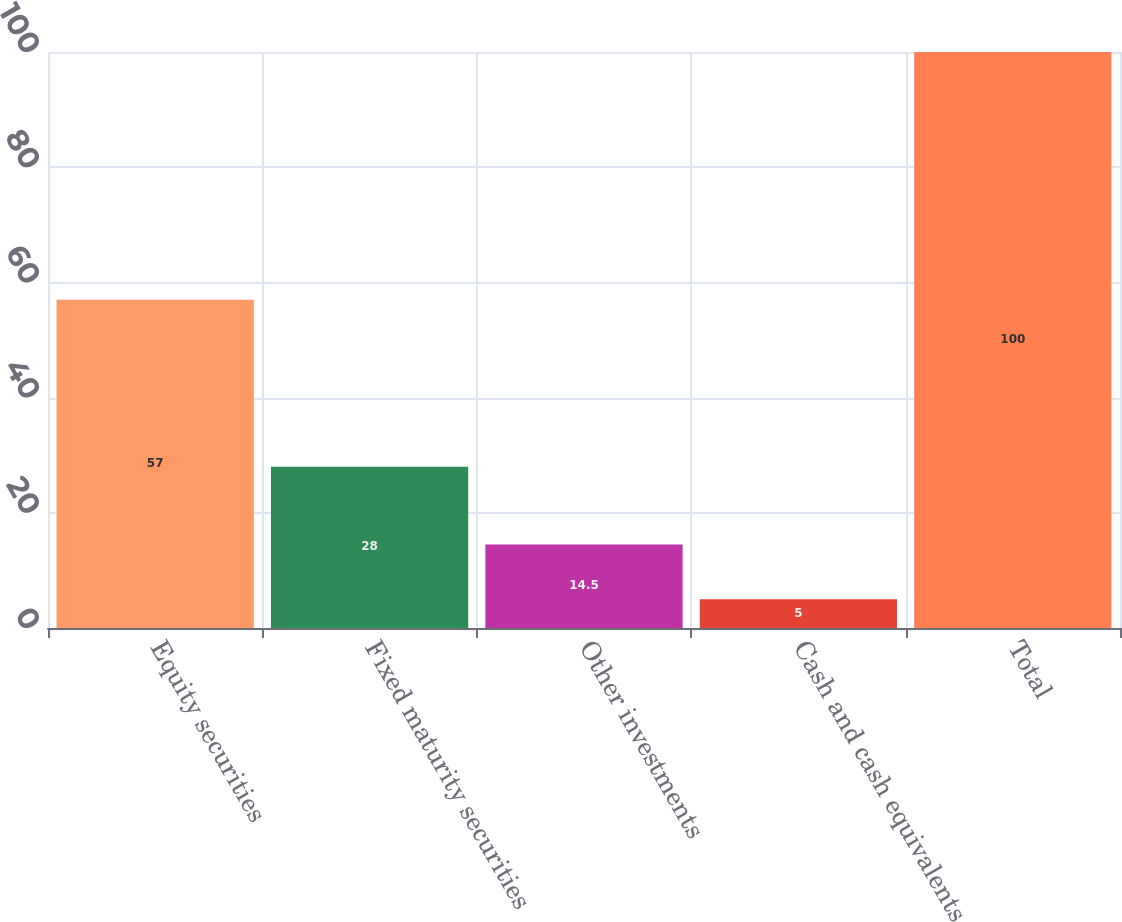Convert chart. <chart><loc_0><loc_0><loc_500><loc_500><bar_chart><fcel>Equity securities<fcel>Fixed maturity securities<fcel>Other investments<fcel>Cash and cash equivalents<fcel>Total<nl><fcel>57<fcel>28<fcel>14.5<fcel>5<fcel>100<nl></chart> 